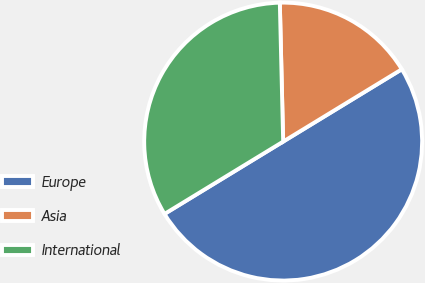<chart> <loc_0><loc_0><loc_500><loc_500><pie_chart><fcel>Europe<fcel>Asia<fcel>International<nl><fcel>50.0%<fcel>16.67%<fcel>33.33%<nl></chart> 